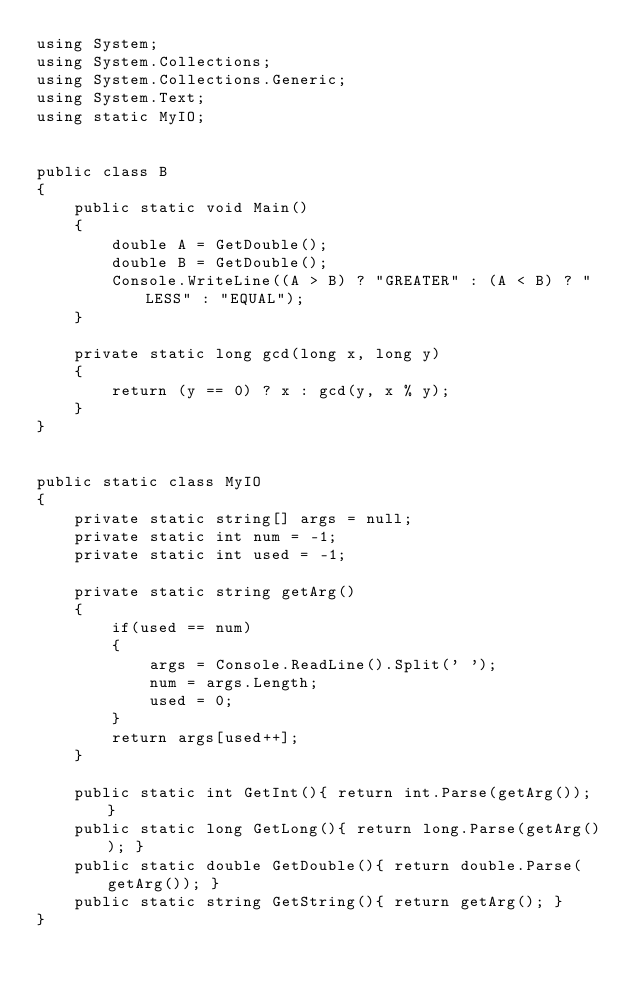Convert code to text. <code><loc_0><loc_0><loc_500><loc_500><_C#_>using System;
using System.Collections;
using System.Collections.Generic;
using System.Text;
using static MyIO;


public class B
{
	public static void Main()	
	{
		double A = GetDouble();
		double B = GetDouble();
		Console.WriteLine((A > B) ? "GREATER" : (A < B) ? "LESS" : "EQUAL");
	}

	private static long gcd(long x, long y)
	{
		return (y == 0) ? x : gcd(y, x % y);
	}
}


public static class MyIO
{
	private static string[] args = null;
	private static int num = -1;
	private static int used = -1;

	private static string getArg()
	{
		if(used == num)
		{
			args = Console.ReadLine().Split(' ');
			num = args.Length;
			used = 0;
		}
		return args[used++];
	}

	public static int GetInt(){ return int.Parse(getArg()); }
	public static long GetLong(){ return long.Parse(getArg()); }
	public static double GetDouble(){ return double.Parse(getArg()); }
	public static string GetString(){ return getArg(); }
}
</code> 